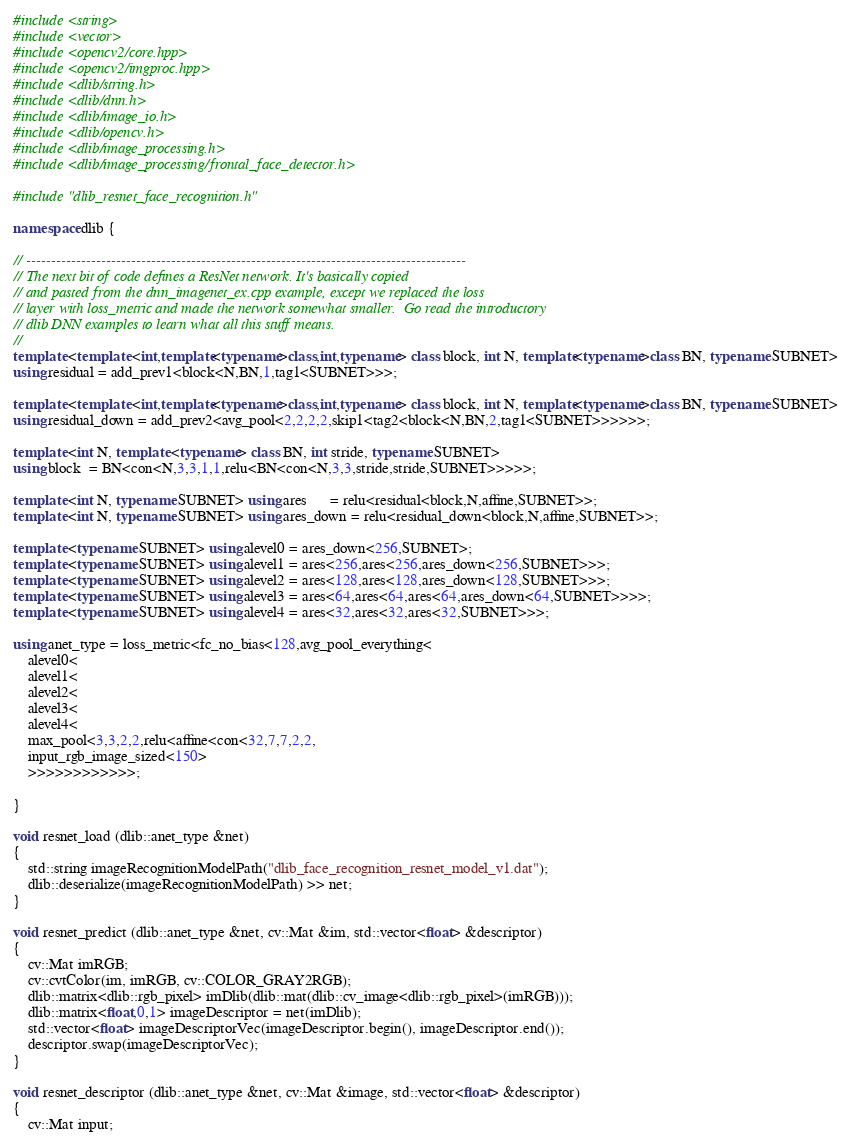<code> <loc_0><loc_0><loc_500><loc_500><_C++_>#include <string>
#include <vector>
#include <opencv2/core.hpp>
#include <opencv2/imgproc.hpp>
#include <dlib/string.h>
#include <dlib/dnn.h>
#include <dlib/image_io.h>
#include <dlib/opencv.h>
#include <dlib/image_processing.h>
#include <dlib/image_processing/frontal_face_detector.h>

#include "dlib_resnet_face_recognition.h"

namespace dlib {

// ----------------------------------------------------------------------------------------
// The next bit of code defines a ResNet network. It's basically copied
// and pasted from the dnn_imagenet_ex.cpp example, except we replaced the loss
// layer with loss_metric and made the network somewhat smaller.  Go read the introductory
// dlib DNN examples to learn what all this stuff means.
//
template <template <int,template<typename>class,int,typename> class block, int N, template<typename>class BN, typename SUBNET>
using residual = add_prev1<block<N,BN,1,tag1<SUBNET>>>;

template <template <int,template<typename>class,int,typename> class block, int N, template<typename>class BN, typename SUBNET>
using residual_down = add_prev2<avg_pool<2,2,2,2,skip1<tag2<block<N,BN,2,tag1<SUBNET>>>>>>;

template <int N, template <typename> class BN, int stride, typename SUBNET> 
using block  = BN<con<N,3,3,1,1,relu<BN<con<N,3,3,stride,stride,SUBNET>>>>>;

template <int N, typename SUBNET> using ares      = relu<residual<block,N,affine,SUBNET>>;
template <int N, typename SUBNET> using ares_down = relu<residual_down<block,N,affine,SUBNET>>;

template <typename SUBNET> using alevel0 = ares_down<256,SUBNET>;
template <typename SUBNET> using alevel1 = ares<256,ares<256,ares_down<256,SUBNET>>>;
template <typename SUBNET> using alevel2 = ares<128,ares<128,ares_down<128,SUBNET>>>;
template <typename SUBNET> using alevel3 = ares<64,ares<64,ares<64,ares_down<64,SUBNET>>>>;
template <typename SUBNET> using alevel4 = ares<32,ares<32,ares<32,SUBNET>>>;

using anet_type = loss_metric<fc_no_bias<128,avg_pool_everything<
    alevel0<
    alevel1<
    alevel2<
    alevel3<
    alevel4<
    max_pool<3,3,2,2,relu<affine<con<32,7,7,2,2,
    input_rgb_image_sized<150>
    >>>>>>>>>>>>;

}

void resnet_load (dlib::anet_type &net)
{
    std::string imageRecognitionModelPath("dlib_face_recognition_resnet_model_v1.dat");
    dlib::deserialize(imageRecognitionModelPath) >> net;
}

void resnet_predict (dlib::anet_type &net, cv::Mat &im, std::vector<float> &descriptor)
{
    cv::Mat imRGB;
    cv::cvtColor(im, imRGB, cv::COLOR_GRAY2RGB);
    dlib::matrix<dlib::rgb_pixel> imDlib(dlib::mat(dlib::cv_image<dlib::rgb_pixel>(imRGB)));
    dlib::matrix<float,0,1> imageDescriptor = net(imDlib);
    std::vector<float> imageDescriptorVec(imageDescriptor.begin(), imageDescriptor.end());
    descriptor.swap(imageDescriptorVec);
}

void resnet_descriptor (dlib::anet_type &net, cv::Mat &image, std::vector<float> &descriptor)
{
    cv::Mat input;</code> 